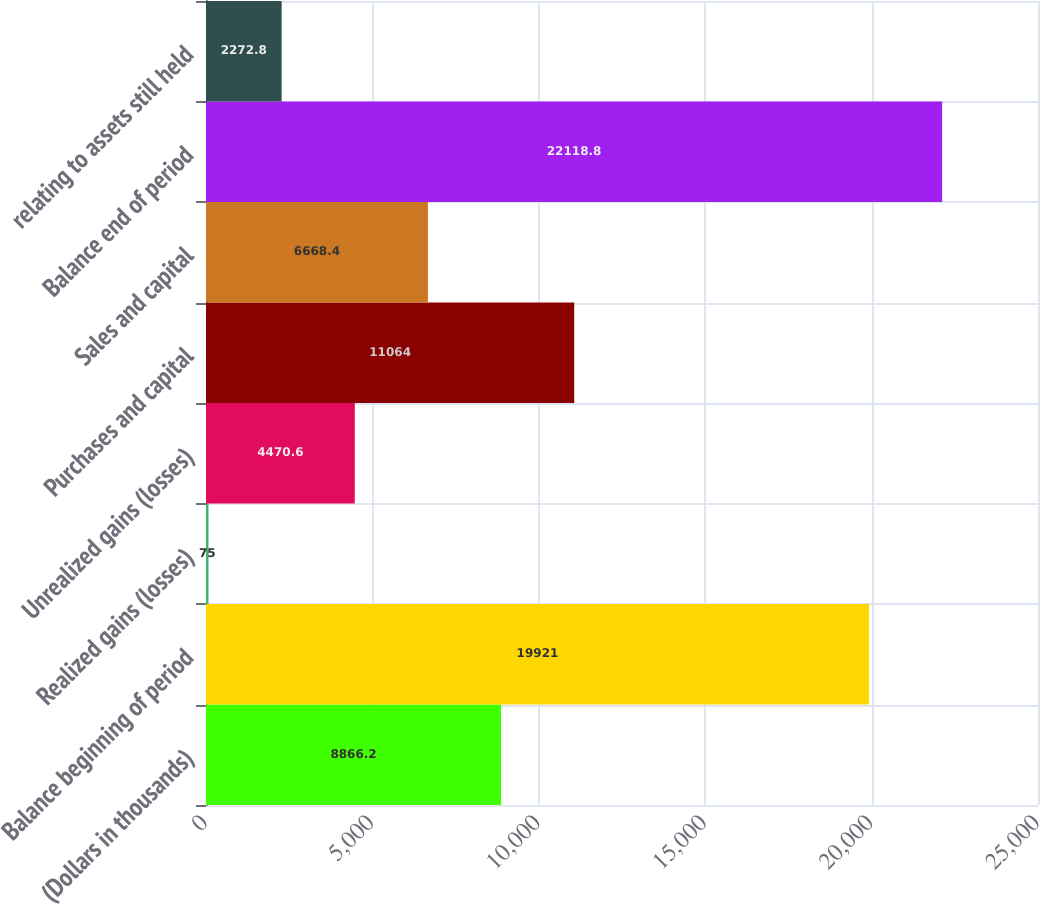Convert chart to OTSL. <chart><loc_0><loc_0><loc_500><loc_500><bar_chart><fcel>(Dollars in thousands)<fcel>Balance beginning of period<fcel>Realized gains (losses)<fcel>Unrealized gains (losses)<fcel>Purchases and capital<fcel>Sales and capital<fcel>Balance end of period<fcel>relating to assets still held<nl><fcel>8866.2<fcel>19921<fcel>75<fcel>4470.6<fcel>11064<fcel>6668.4<fcel>22118.8<fcel>2272.8<nl></chart> 